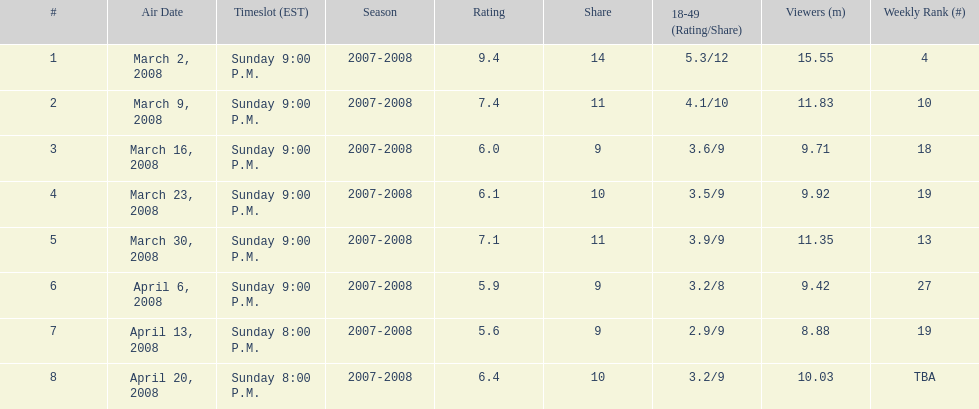How many programs attracted a minimum of 10 million viewers? 4. 